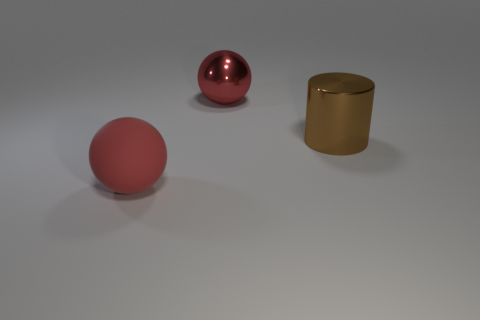What atmosphere or mood does the combination of objects and colors in the image create? The selection and placement of the objects, along with the muted color palette, gives the image a minimalistic and modern aesthetic. The warm tones of the gold cylinder and the cool shades of the red sphere contrast against the neutral background, creating a sense of balance and tranquility. 